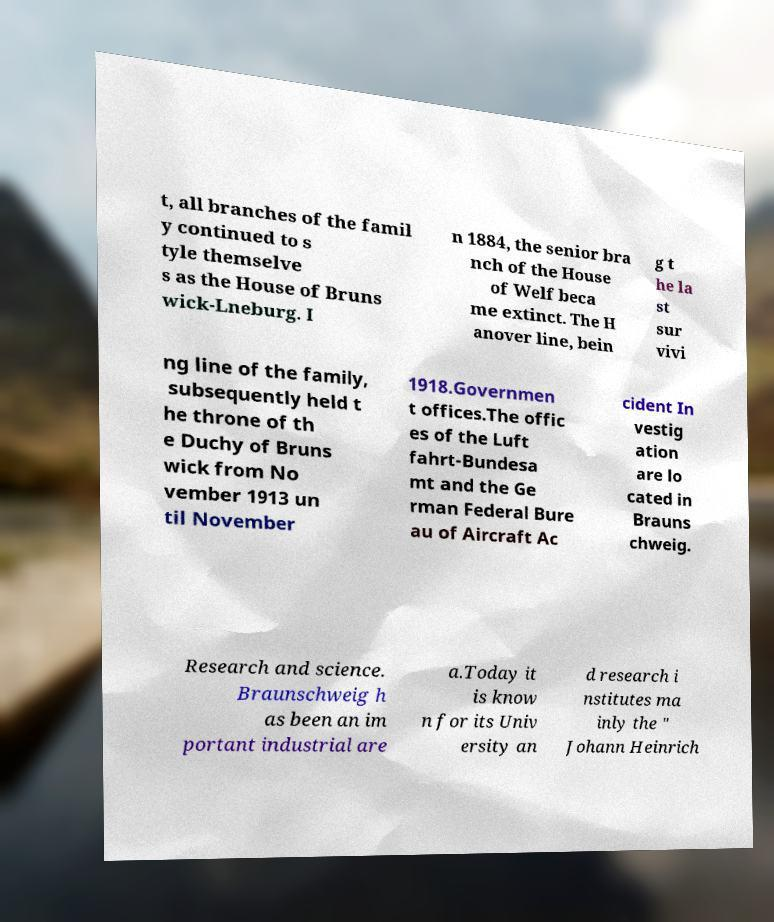I need the written content from this picture converted into text. Can you do that? t, all branches of the famil y continued to s tyle themselve s as the House of Bruns wick-Lneburg. I n 1884, the senior bra nch of the House of Welf beca me extinct. The H anover line, bein g t he la st sur vivi ng line of the family, subsequently held t he throne of th e Duchy of Bruns wick from No vember 1913 un til November 1918.Governmen t offices.The offic es of the Luft fahrt-Bundesa mt and the Ge rman Federal Bure au of Aircraft Ac cident In vestig ation are lo cated in Brauns chweig. Research and science. Braunschweig h as been an im portant industrial are a.Today it is know n for its Univ ersity an d research i nstitutes ma inly the " Johann Heinrich 